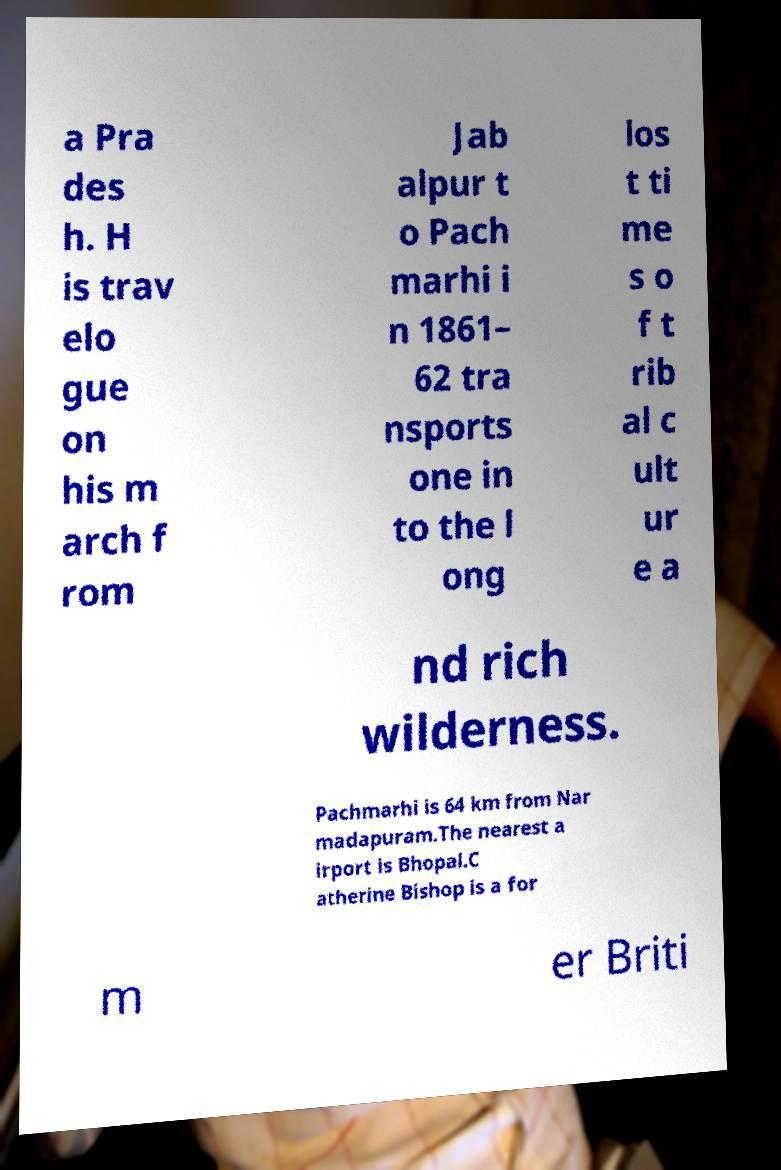For documentation purposes, I need the text within this image transcribed. Could you provide that? a Pra des h. H is trav elo gue on his m arch f rom Jab alpur t o Pach marhi i n 1861– 62 tra nsports one in to the l ong los t ti me s o f t rib al c ult ur e a nd rich wilderness. Pachmarhi is 64 km from Nar madapuram.The nearest a irport is Bhopal.C atherine Bishop is a for m er Briti 